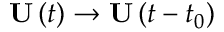<formula> <loc_0><loc_0><loc_500><loc_500>U \left ( t \right ) \to U \left ( t - t _ { 0 } \right )</formula> 